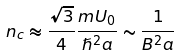Convert formula to latex. <formula><loc_0><loc_0><loc_500><loc_500>n _ { c } \approx \frac { \sqrt { 3 } } { 4 } \frac { m U _ { 0 } } { \hslash ^ { 2 } a } \sim \frac { 1 } { B ^ { 2 } a }</formula> 